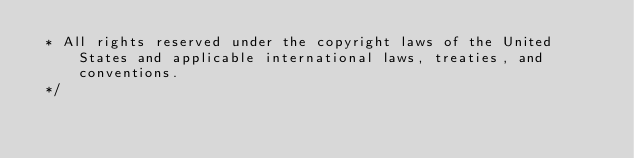<code> <loc_0><loc_0><loc_500><loc_500><_JavaScript_> * All rights reserved under the copyright laws of the United States and applicable international laws, treaties, and conventions.
 */</code> 